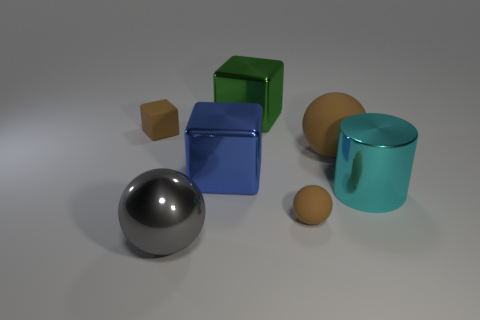There is a metallic block that is behind the brown rubber object on the left side of the large gray sphere; what is its color?
Keep it short and to the point. Green. Does the cyan metallic cylinder have the same size as the green shiny cube?
Offer a terse response. Yes. Is the material of the tiny brown thing that is in front of the cyan metal object the same as the tiny brown thing that is behind the big brown rubber thing?
Ensure brevity in your answer.  Yes. There is a small brown thing right of the big metallic object behind the brown rubber ball that is behind the cylinder; what shape is it?
Provide a succinct answer. Sphere. Is the number of spheres greater than the number of big metal objects?
Provide a succinct answer. No. Are there any small brown balls?
Provide a succinct answer. Yes. How many objects are either rubber balls in front of the big matte object or things in front of the big brown matte thing?
Keep it short and to the point. 4. Is the small matte sphere the same color as the shiny cylinder?
Provide a short and direct response. No. Are there fewer cyan metal objects than large shiny things?
Make the answer very short. Yes. There is a big cyan cylinder; are there any brown matte blocks behind it?
Your answer should be compact. Yes. 